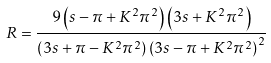<formula> <loc_0><loc_0><loc_500><loc_500>R = \frac { 9 \left ( s - \pi + K ^ { 2 } \pi ^ { 2 } \right ) \left ( 3 s + K ^ { 2 } \pi ^ { 2 } \right ) } { \left ( 3 s + \pi - K ^ { 2 } \pi ^ { 2 } \right ) \left ( 3 s - \pi + K ^ { 2 } \pi ^ { 2 } \right ) ^ { 2 } }</formula> 